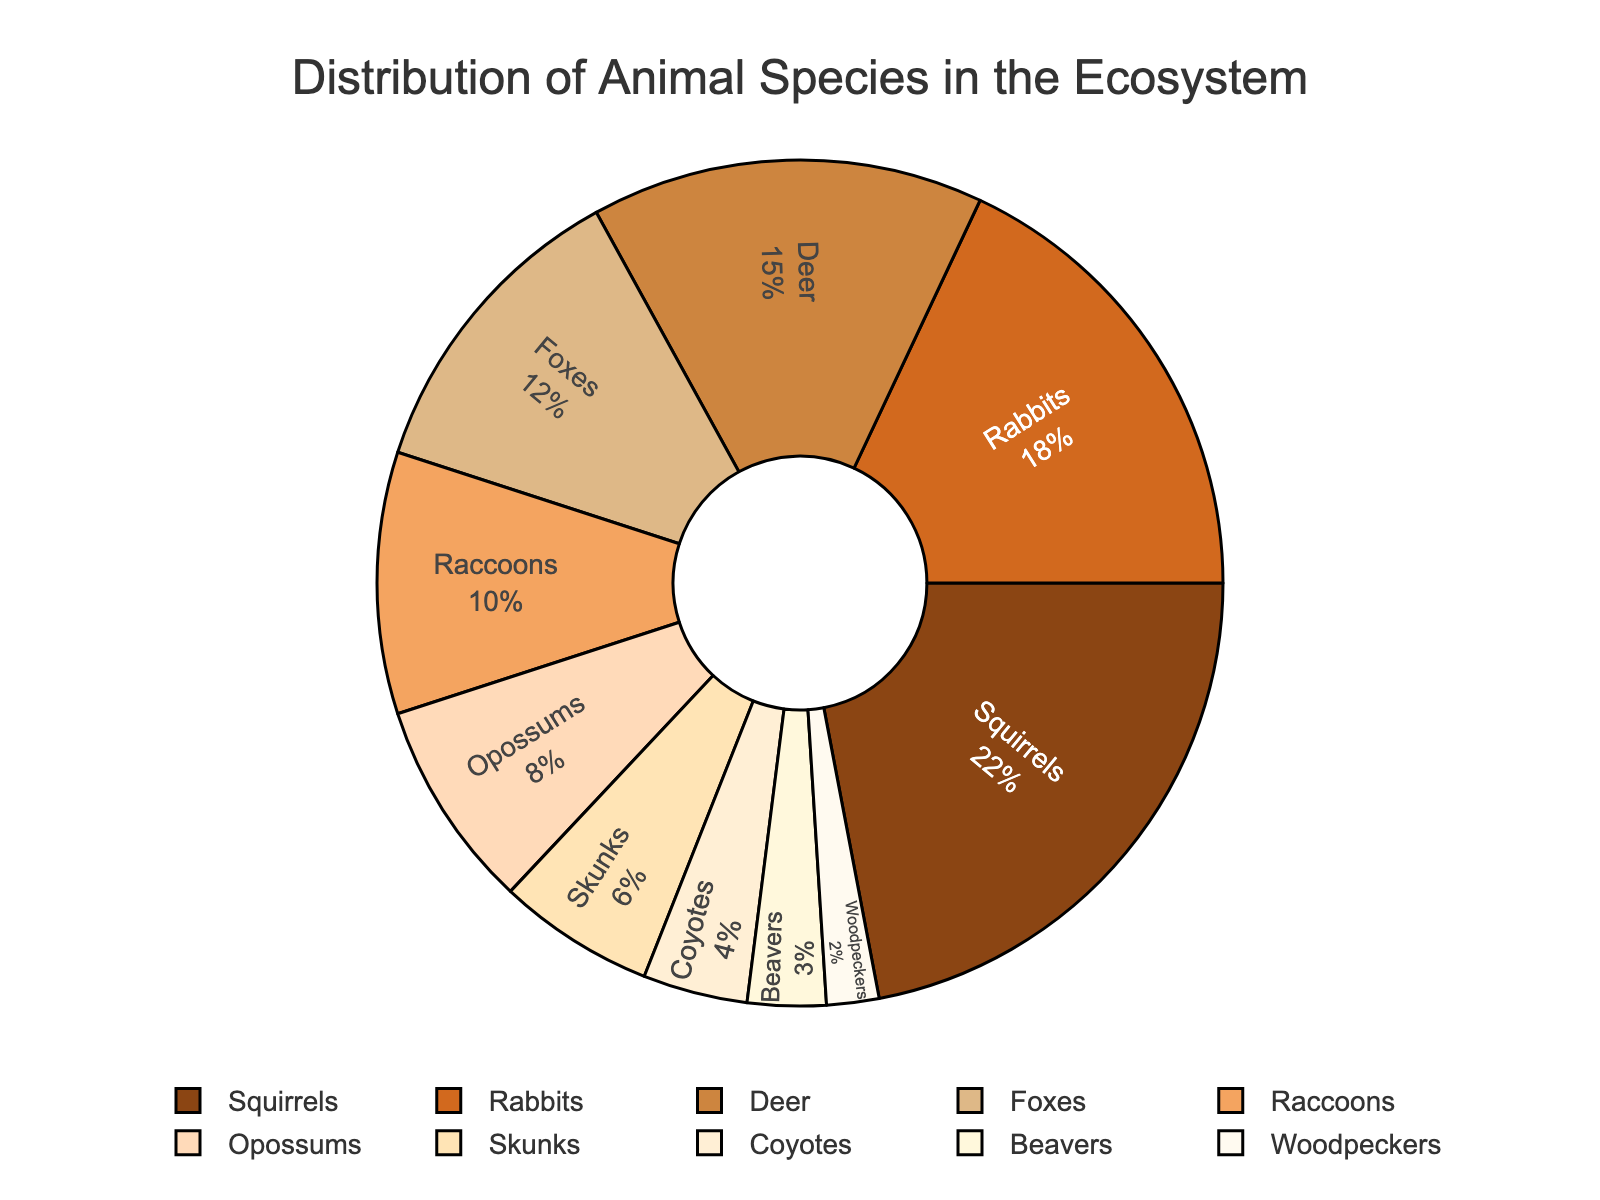What is the most common animal species in the ecosystem? The chart shows various species labeled with their population percentages. Squirrels have the highest percentage.
Answer: Squirrels Which two species have a combined population percentage equal to the population percentage of squirrels? Squirrels have a population percentage of 22%. Rabbits (18%) and Beavers (3%) combined make 21%, whereas Rabbits (18%) and Woodpeckers (2%) combined make 20%. No two species combined exactly equal 22%, but Rabbits and another small percentage species like Beavers or Woodpeckers come closest.
Answer: None exactly, but Rabbits and another small percent species (e.g., Beavers or Woodpeckers) Which species group has a lower population percentage than Opossums? By looking at the chart, Skunks (6%), Coyotes (4%), Beavers (3%), and Woodpeckers (2%) have lower percentages than Opossums (8%).
Answer: Skunks, Coyotes, Beavers, Woodpeckers What is the total population percentage of nocturnal species like Raccoons, Opossums, and Skunks? Adding up the percentages of Raccoons (10%), Opossums (8%), and Skunks (6%) gives a total of 24%.
Answer: 24% Which species has a population percentage that is exactly half of the population percentage of Foxes? Foxes have a population percentage of 12%. Half of this is 6%, which corresponds to Skunks.
Answer: Skunks What is the difference in population percentage between the most common species and the least common species? The most common species, Squirrels, have 22%, and the least common species, Woodpeckers, have 2%. The difference is 22% - 2% = 20%.
Answer: 20% Which species have percentages that are greater than the median population percentage value? The median value for this dataset (ordered: 2, 3, 4, 6, 8, 10, 12, 15, 18, 22) is the average of the 5th and 6th values, which are Opossums (8%) and Raccoons (10%). The average is (8+10)/2 = 9. Thus, species with percentages greater than 9% are Squirrels, Rabbits, Deer, Foxes, and Raccoons.
Answer: Squirrels, Rabbits, Deer, Foxes, and Raccoons What colors are used to represent the top three most prevalent species? Reviewing the pie chart’s color segments, the colors for Squirrels (#8B4513), Rabbits (#D2691E), and Deer (#CD853F) are brown, chocolate, and tan respectively.
Answer: Brown, Chocolate, Tan 